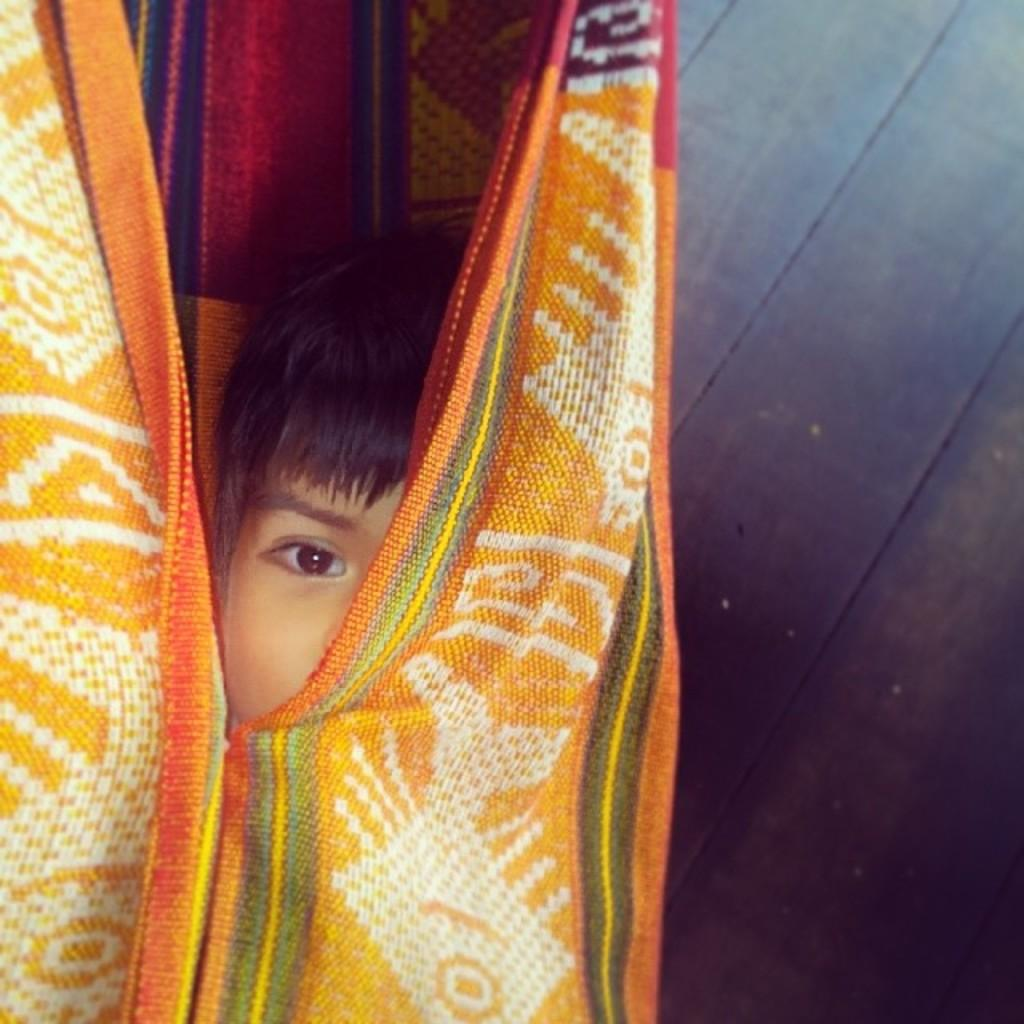What is the main subject of the image? The main subject of the image is a kid. What is the kid wearing in the image? The kid is wearing a cloth in the image. What type of surface is visible in the image? There is a floor visible in the image. How many rings does the kid have on their fingers in the image? There is no mention of rings in the image, so it cannot be determined if the kid has any rings on their fingers. 